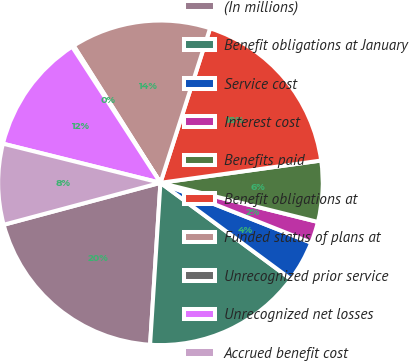Convert chart. <chart><loc_0><loc_0><loc_500><loc_500><pie_chart><fcel>(In millions)<fcel>Benefit obligations at January<fcel>Service cost<fcel>Interest cost<fcel>Benefits paid<fcel>Benefit obligations at<fcel>Funded status of plans at<fcel>Unrecognized prior service<fcel>Unrecognized net losses<fcel>Accrued benefit cost<nl><fcel>19.82%<fcel>15.89%<fcel>4.11%<fcel>2.14%<fcel>6.07%<fcel>17.86%<fcel>13.93%<fcel>0.18%<fcel>11.96%<fcel>8.04%<nl></chart> 